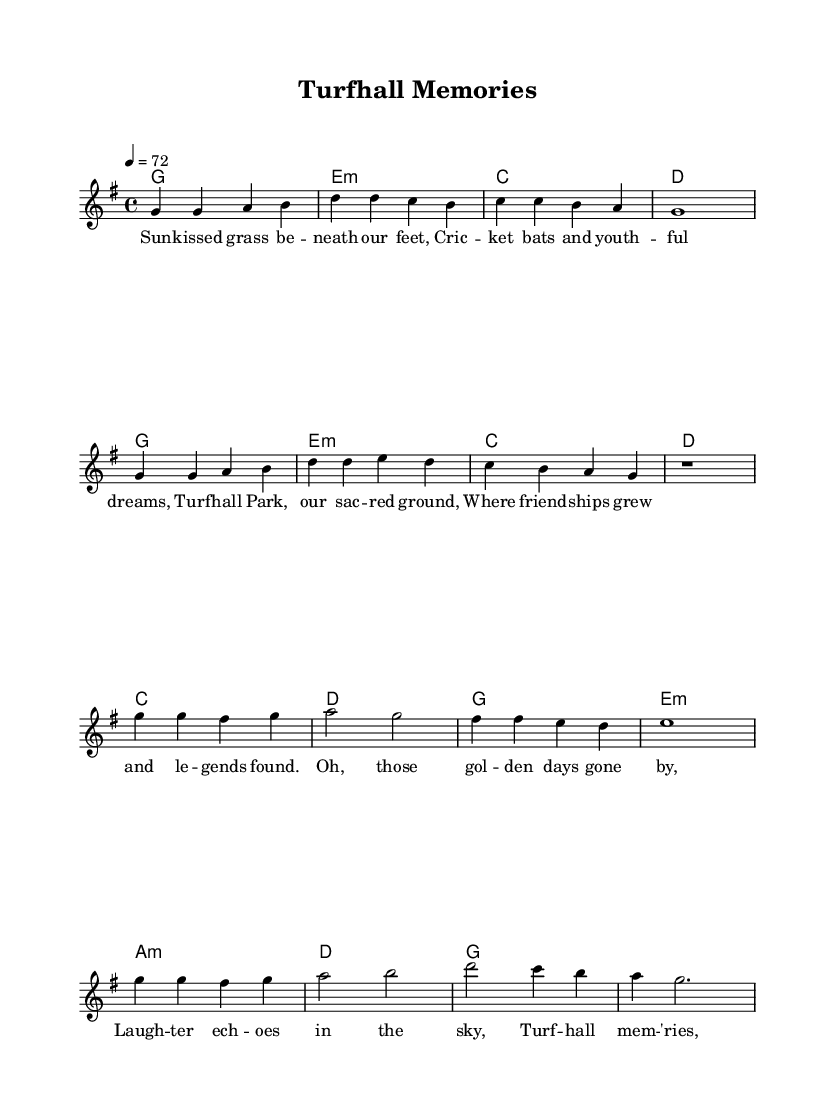What is the key signature of this music? The key signature is G major, which has one sharp (F#). It's indicated at the beginning of the score after the clef.
Answer: G major What is the time signature of this music? The time signature is 4/4, shown at the beginning of the score. This means there are four beats in each measure and a quarter note receives one beat.
Answer: 4/4 What is the tempo marking for this piece? The tempo marking is "4 = 72," meaning the quarter note is to be played at a speed of 72 beats per minute. This is indicated right after the time signature.
Answer: 72 How many measures are in the verse? The verse consists of 8 measures, counted by the divisions in the notation. The two-part verse sequence is clearly distinguishable.
Answer: 8 measures What is the chord progression used in the chorus? The chord progression for the chorus is C, D, G, E minor, A minor, D, G, as listed under the ChordNames. This reflects the harmonic structure of the chorus section.
Answer: C, D, G, E minor, A minor, D, G Which theme from the lyrics does the music evoke? The lyrics evoke themes of nostalgia and cherished memories centered around the experiences at Turfhall Park. This feeling is captured in both the verse and chorus lyrics.
Answer: Nostalgia What is the last note of the melody? The last note of the melody in the provided score is a G note, indicated in the final measure of the chorus. This denotes the end of the musical phrase.
Answer: G 